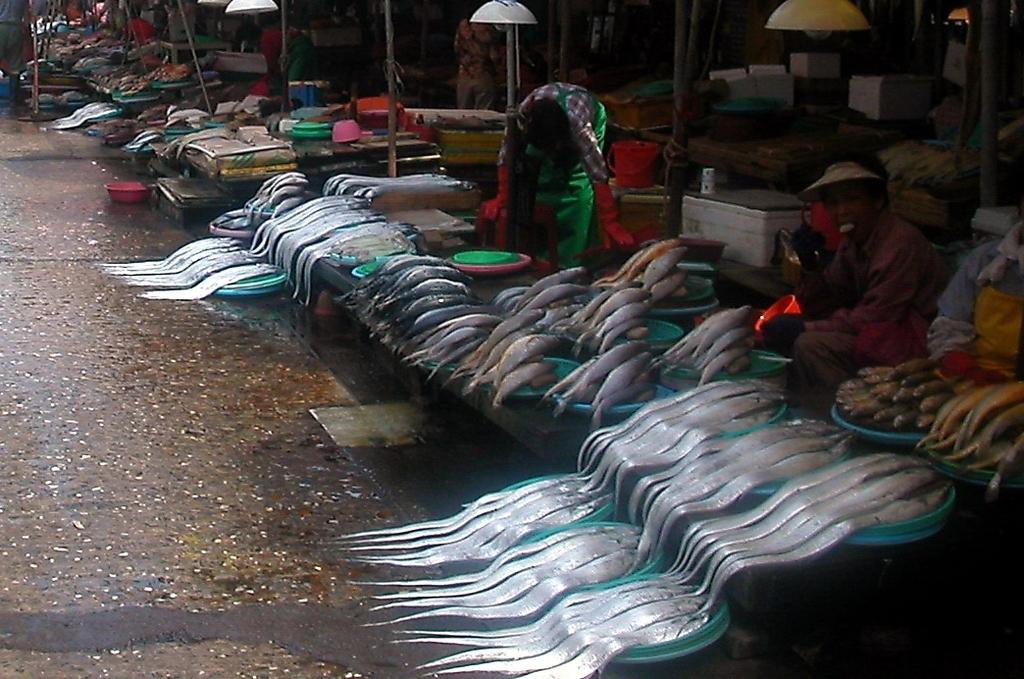What type of market is depicted in the image? The image appears to be a fish market. What can be found in the fish market? There are fishes in bowls in the image. Are there any people present in the fish market? Yes, there are people visible in the fish market. What type of screw is being used to secure the fish in the image? There is no screw present in the image; the fishes are in bowls. How much loss has the fish market experienced in the past year? The provided facts do not include any information about the fish market's financial performance or losses. 